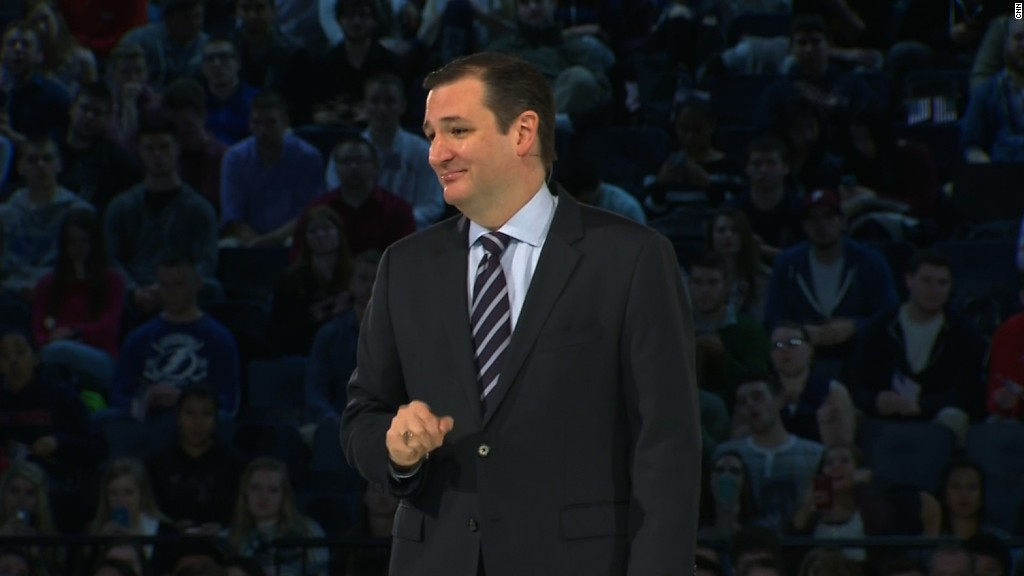Considering real-world scenarios, what might be two possible realistic contexts for this event? Two possible realistic contexts for this event could be:
1. A university guest lecture, where a prominent expert or public figure is invited to speak on a topic of significant interest to students and faculty. The informal attire of the audience and the formal dress of the speaker align with such an academic setting.
2. A town hall meeting organized in a community to discuss important local issues or public policies. The large, informal audience indicates active community involvement, while the speaker's formal presentation suggests an official or authoritative perspective on the topics being addressed.  If this were a public policy debate, what kind of policies might be under discussion? If this were a public policy debate, the policies under discussion could range widely but might include:
1. Educational reforms, focusing on improving the quality of education and access to resources.
2. Healthcare policies, addressing insurance, affordability, and public health initiatives.
3. Environmental policies, discussing measures to combat climate change and promote sustainability.
4. Economic policies, exploring tax reforms, job creation, and income inequality solutions.
5. Social justice initiatives, considering policies to address discrimination, law enforcement practices, and community relations. 